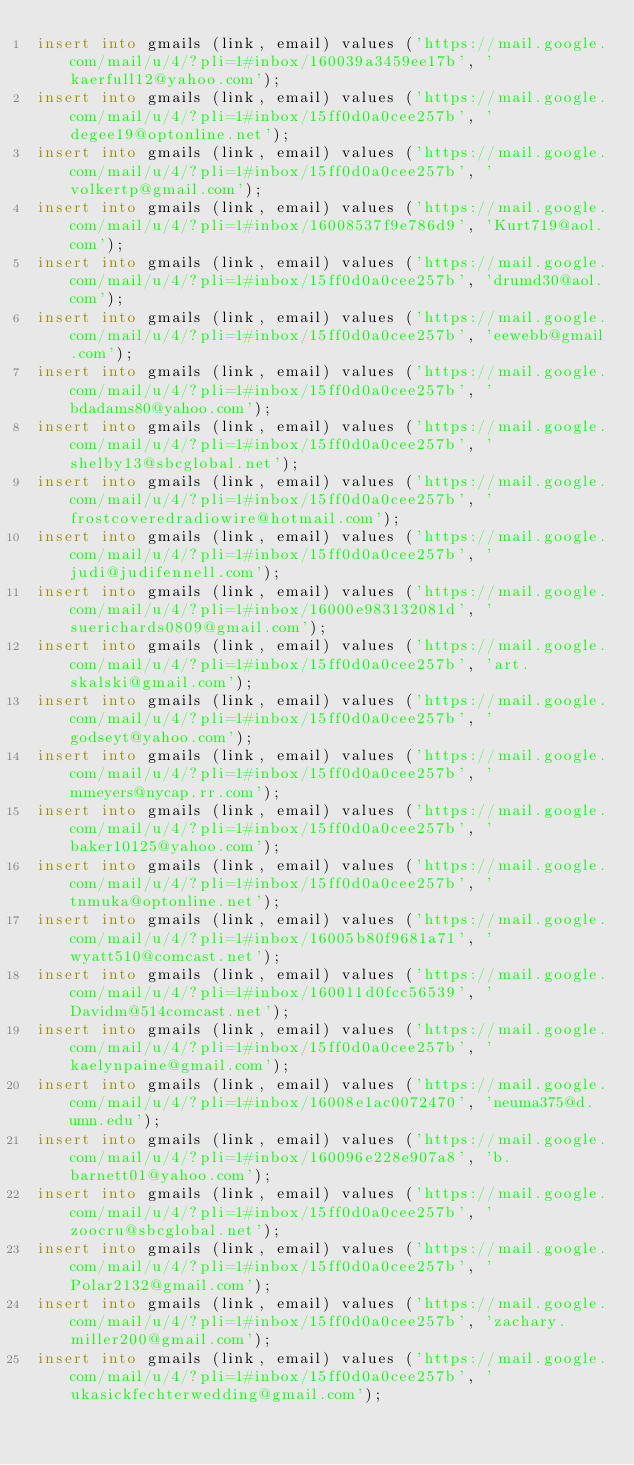<code> <loc_0><loc_0><loc_500><loc_500><_SQL_>insert into gmails (link, email) values ('https://mail.google.com/mail/u/4/?pli=1#inbox/160039a3459ee17b', 'kaerfull12@yahoo.com');
insert into gmails (link, email) values ('https://mail.google.com/mail/u/4/?pli=1#inbox/15ff0d0a0cee257b', 'degee19@optonline.net');
insert into gmails (link, email) values ('https://mail.google.com/mail/u/4/?pli=1#inbox/15ff0d0a0cee257b', 'volkertp@gmail.com');
insert into gmails (link, email) values ('https://mail.google.com/mail/u/4/?pli=1#inbox/16008537f9e786d9', 'Kurt719@aol.com');
insert into gmails (link, email) values ('https://mail.google.com/mail/u/4/?pli=1#inbox/15ff0d0a0cee257b', 'drumd30@aol.com');
insert into gmails (link, email) values ('https://mail.google.com/mail/u/4/?pli=1#inbox/15ff0d0a0cee257b', 'eewebb@gmail.com');
insert into gmails (link, email) values ('https://mail.google.com/mail/u/4/?pli=1#inbox/15ff0d0a0cee257b', 'bdadams80@yahoo.com');
insert into gmails (link, email) values ('https://mail.google.com/mail/u/4/?pli=1#inbox/15ff0d0a0cee257b', 'shelby13@sbcglobal.net');
insert into gmails (link, email) values ('https://mail.google.com/mail/u/4/?pli=1#inbox/15ff0d0a0cee257b', 'frostcoveredradiowire@hotmail.com');
insert into gmails (link, email) values ('https://mail.google.com/mail/u/4/?pli=1#inbox/15ff0d0a0cee257b', 'judi@judifennell.com');
insert into gmails (link, email) values ('https://mail.google.com/mail/u/4/?pli=1#inbox/16000e983132081d', 'suerichards0809@gmail.com');
insert into gmails (link, email) values ('https://mail.google.com/mail/u/4/?pli=1#inbox/15ff0d0a0cee257b', 'art.skalski@gmail.com');
insert into gmails (link, email) values ('https://mail.google.com/mail/u/4/?pli=1#inbox/15ff0d0a0cee257b', 'godseyt@yahoo.com');
insert into gmails (link, email) values ('https://mail.google.com/mail/u/4/?pli=1#inbox/15ff0d0a0cee257b', 'mmeyers@nycap.rr.com');
insert into gmails (link, email) values ('https://mail.google.com/mail/u/4/?pli=1#inbox/15ff0d0a0cee257b', 'baker10125@yahoo.com');
insert into gmails (link, email) values ('https://mail.google.com/mail/u/4/?pli=1#inbox/15ff0d0a0cee257b', 'tnmuka@optonline.net');
insert into gmails (link, email) values ('https://mail.google.com/mail/u/4/?pli=1#inbox/16005b80f9681a71', 'wyatt510@comcast.net');
insert into gmails (link, email) values ('https://mail.google.com/mail/u/4/?pli=1#inbox/160011d0fcc56539', 'Davidm@514comcast.net');
insert into gmails (link, email) values ('https://mail.google.com/mail/u/4/?pli=1#inbox/15ff0d0a0cee257b', 'kaelynpaine@gmail.com');
insert into gmails (link, email) values ('https://mail.google.com/mail/u/4/?pli=1#inbox/16008e1ac0072470', 'neuma375@d.umn.edu');
insert into gmails (link, email) values ('https://mail.google.com/mail/u/4/?pli=1#inbox/160096e228e907a8', 'b.barnett01@yahoo.com');
insert into gmails (link, email) values ('https://mail.google.com/mail/u/4/?pli=1#inbox/15ff0d0a0cee257b', 'zoocru@sbcglobal.net');
insert into gmails (link, email) values ('https://mail.google.com/mail/u/4/?pli=1#inbox/15ff0d0a0cee257b', 'Polar2132@gmail.com');
insert into gmails (link, email) values ('https://mail.google.com/mail/u/4/?pli=1#inbox/15ff0d0a0cee257b', 'zachary.miller200@gmail.com');
insert into gmails (link, email) values ('https://mail.google.com/mail/u/4/?pli=1#inbox/15ff0d0a0cee257b', 'ukasickfechterwedding@gmail.com');</code> 